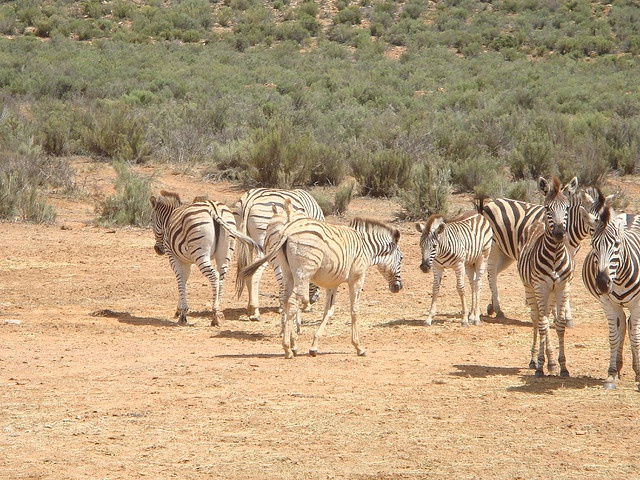Describe the objects in this image and their specific colors. I can see zebra in gray, tan, and beige tones, zebra in gray, tan, and maroon tones, zebra in gray and tan tones, zebra in gray, tan, darkgray, and ivory tones, and zebra in gray, beige, and tan tones in this image. 